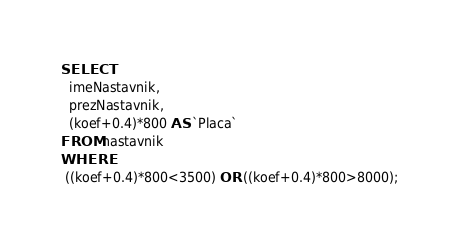<code> <loc_0><loc_0><loc_500><loc_500><_SQL_>SELECT 
  imeNastavnik,
  prezNastavnik,
  (koef+0.4)*800 AS `Placa`
FROM nastavnik
WHERE
 ((koef+0.4)*800<3500) OR ((koef+0.4)*800>8000);</code> 